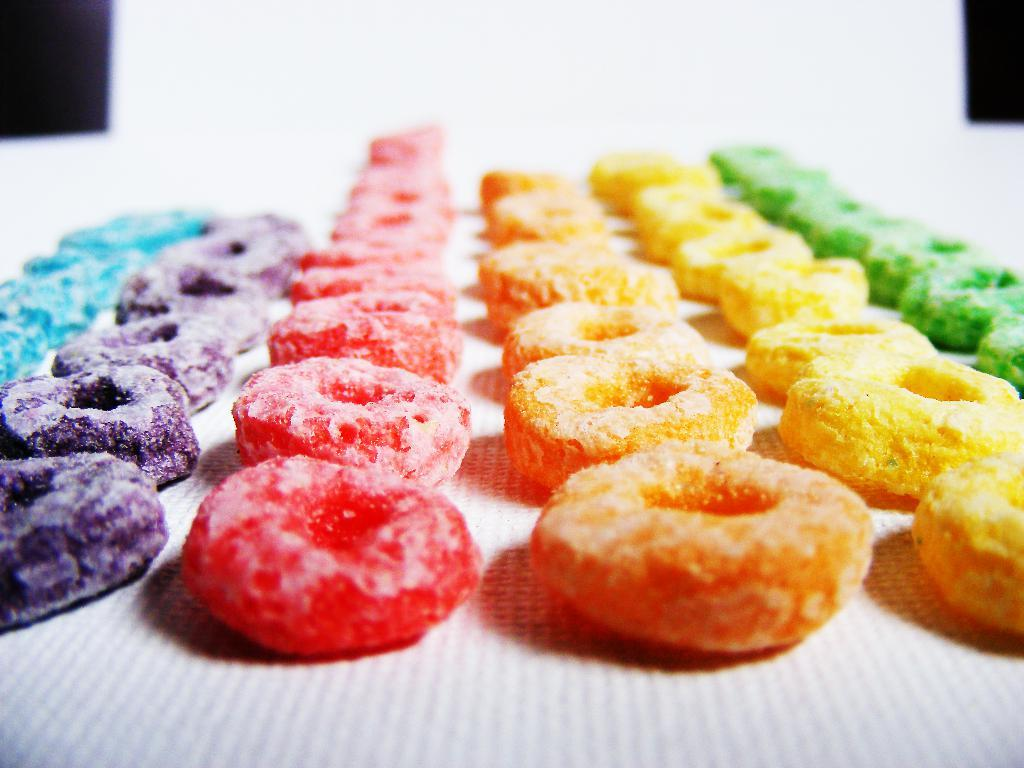What type of objects are arranged in rows in the image? There are different colors of candies in the image, arranged in rows. What is the candies placed on? The candies are on a paper. What can be seen in the background of the image? There is a wall in the background of the image. What time of day is it in the image, and how does the night express regret? The time of day is not mentioned in the image, and candies do not express regret. 